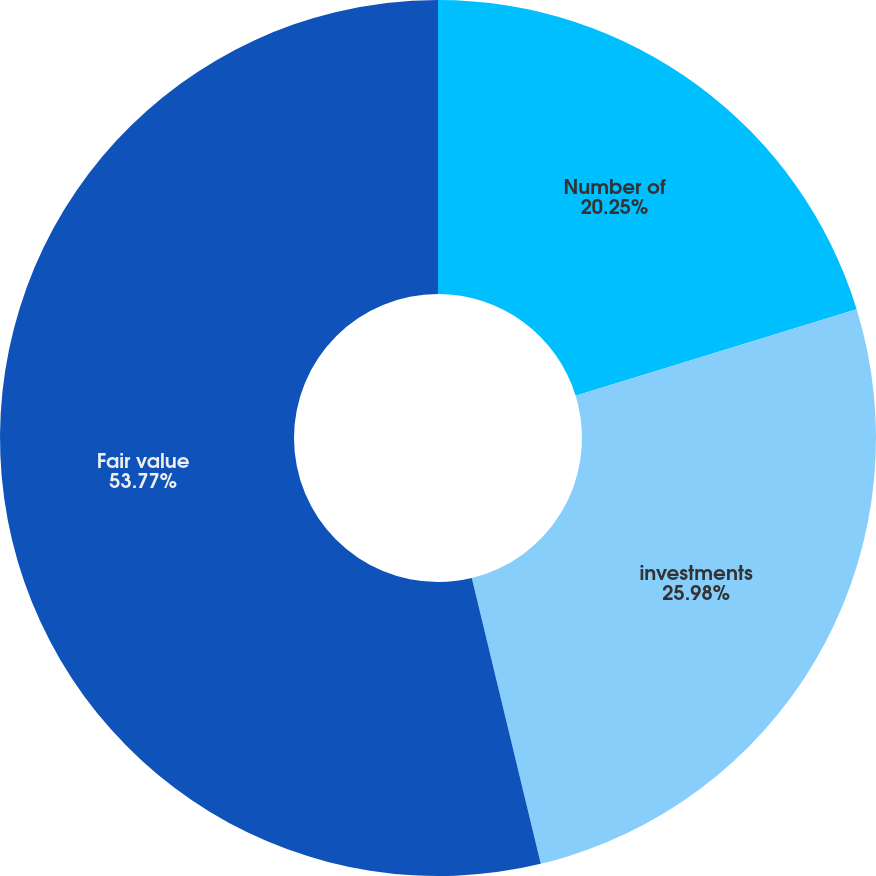<chart> <loc_0><loc_0><loc_500><loc_500><pie_chart><fcel>Number of<fcel>investments<fcel>Fair value<nl><fcel>20.25%<fcel>25.98%<fcel>53.77%<nl></chart> 